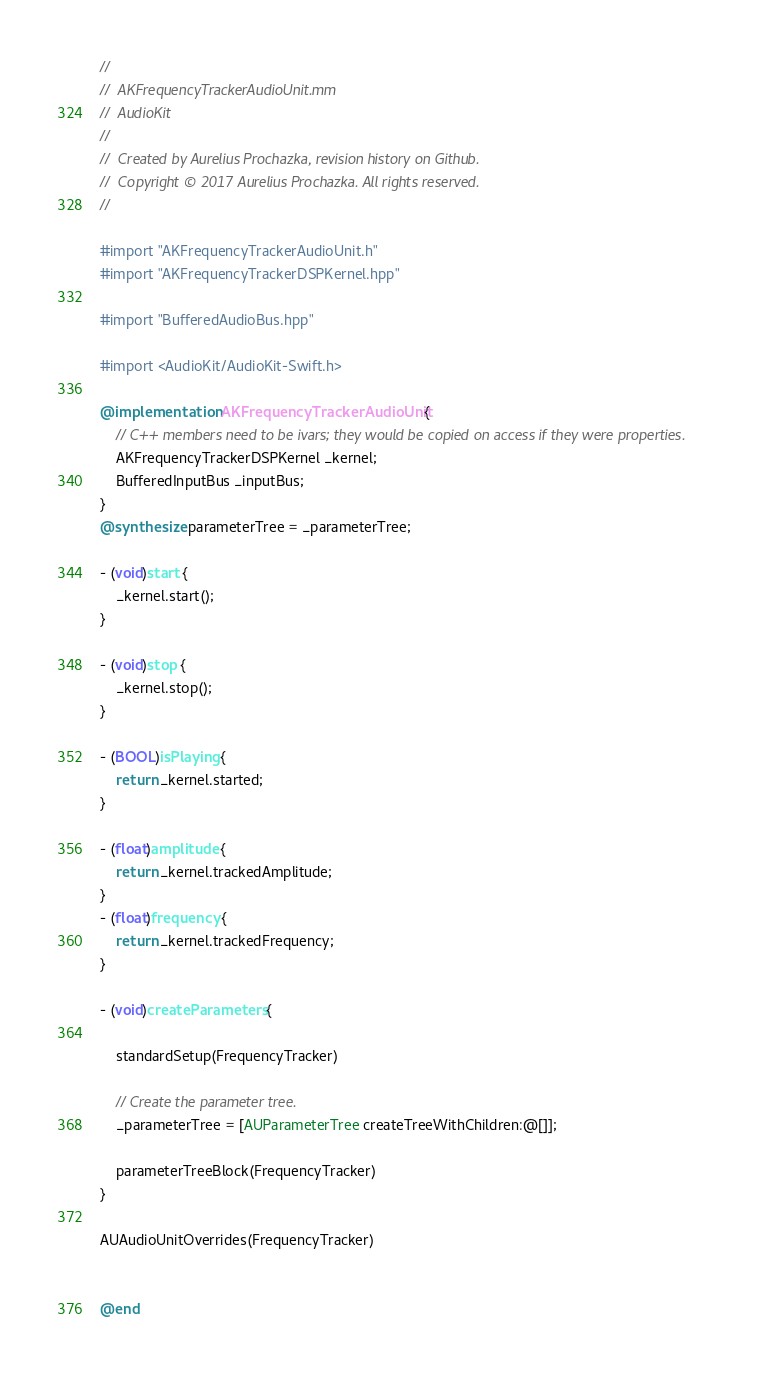<code> <loc_0><loc_0><loc_500><loc_500><_ObjectiveC_>//
//  AKFrequencyTrackerAudioUnit.mm
//  AudioKit
//
//  Created by Aurelius Prochazka, revision history on Github.
//  Copyright © 2017 Aurelius Prochazka. All rights reserved.
//

#import "AKFrequencyTrackerAudioUnit.h"
#import "AKFrequencyTrackerDSPKernel.hpp"

#import "BufferedAudioBus.hpp"

#import <AudioKit/AudioKit-Swift.h>

@implementation AKFrequencyTrackerAudioUnit {
    // C++ members need to be ivars; they would be copied on access if they were properties.
    AKFrequencyTrackerDSPKernel _kernel;
    BufferedInputBus _inputBus;
}
@synthesize parameterTree = _parameterTree;

- (void)start {
    _kernel.start();
}

- (void)stop {
    _kernel.stop();
}

- (BOOL)isPlaying {
    return _kernel.started;
}

- (float)amplitude {
    return _kernel.trackedAmplitude;
}
- (float)frequency {
    return _kernel.trackedFrequency;
}

- (void)createParameters {

    standardSetup(FrequencyTracker)

    // Create the parameter tree.
    _parameterTree = [AUParameterTree createTreeWithChildren:@[]];

    parameterTreeBlock(FrequencyTracker)
}

AUAudioUnitOverrides(FrequencyTracker)


@end


</code> 